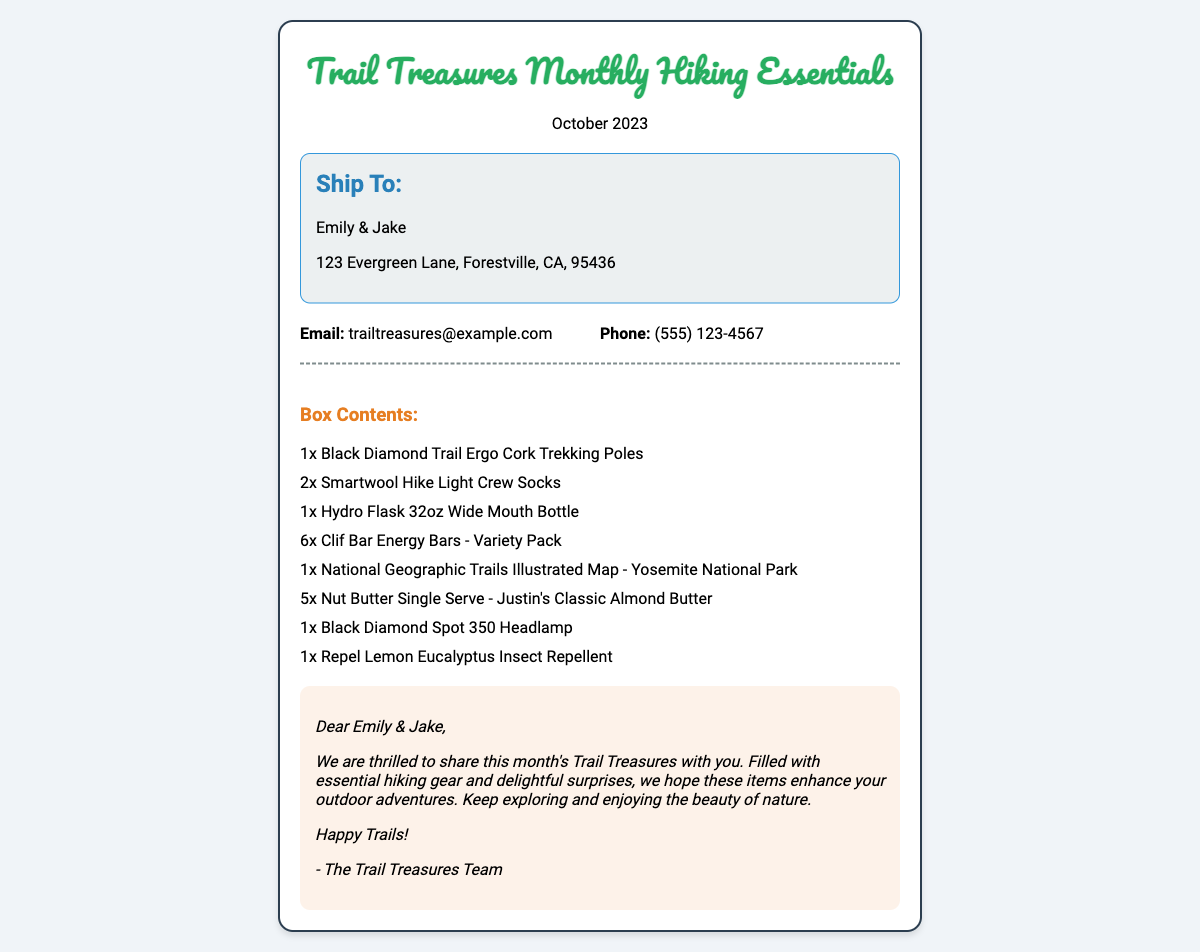What is the title of the subscription box? The title of the subscription box is prominently displayed at the top of the document, which indicates the nature and theme of the contents.
Answer: Trail Treasures Monthly Hiking Essentials What month is this shipping label for? The month is indicated right under the title and signifies the specific period for which the box is curated.
Answer: October 2023 Who is the intended recipient? The recipient's name is provided in the shipping address section, specifying to whom the box will be sent.
Answer: Emily & Jake How many trekking poles are included in the box? The quantity of trekking poles is listed in the box contents, which denotes the number of items of that type included.
Answer: 1x What is the total number of Clif Bar Energy Bars in the box? The item count for the Clif Bar Energy Bars is specified, representing the total included in the subscription box.
Answer: 6x What type of insect repellent is included? The specific type of insect repellent is found within the box contents section, indicating what is provided for outdoor use.
Answer: Repel Lemon Eucalyptus Insect Repellent What is the contact email provided? The contact email is listed under contact information, used for customer inquiries regarding the subscription box.
Answer: trailtreasures@example.com What custom message is included with the box? The custom message is directly stated in the document, indicating the personal touch aimed at the recipient.
Answer: We are thrilled to share this month's Trail Treasures with you 